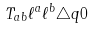Convert formula to latex. <formula><loc_0><loc_0><loc_500><loc_500>T _ { a b } \ell ^ { a } \ell ^ { b } \triangle q 0</formula> 